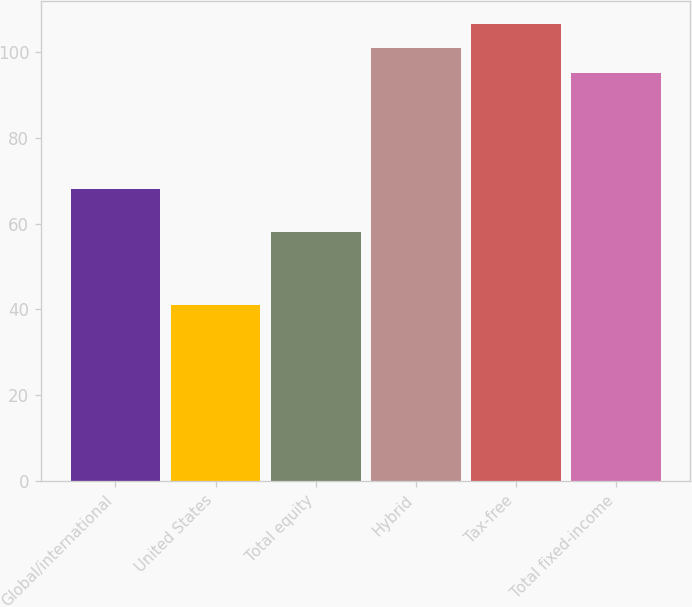Convert chart. <chart><loc_0><loc_0><loc_500><loc_500><bar_chart><fcel>Global/international<fcel>United States<fcel>Total equity<fcel>Hybrid<fcel>Tax-free<fcel>Total fixed-income<nl><fcel>68<fcel>41<fcel>58<fcel>100.8<fcel>106.6<fcel>95<nl></chart> 